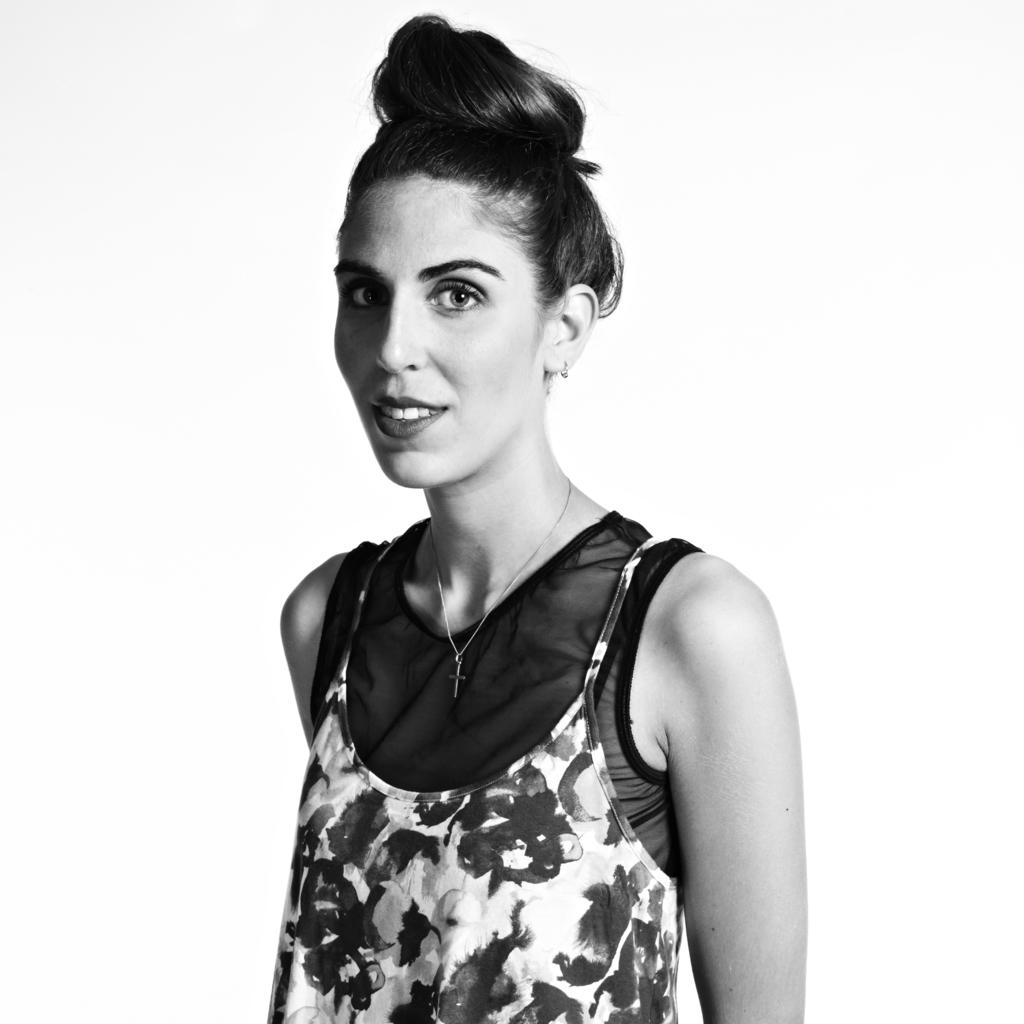Who is present in the image? There is a woman in the image. What is the woman wearing? The woman is wearing a floral dress. What is the woman doing in the image? The woman is standing and smiling. What is the background of the image? There is a white background in the image. What type of popcorn can be seen on the woman's head in the image? There is no popcorn present in the image, and therefore no such item can be seen on the woman's head. 